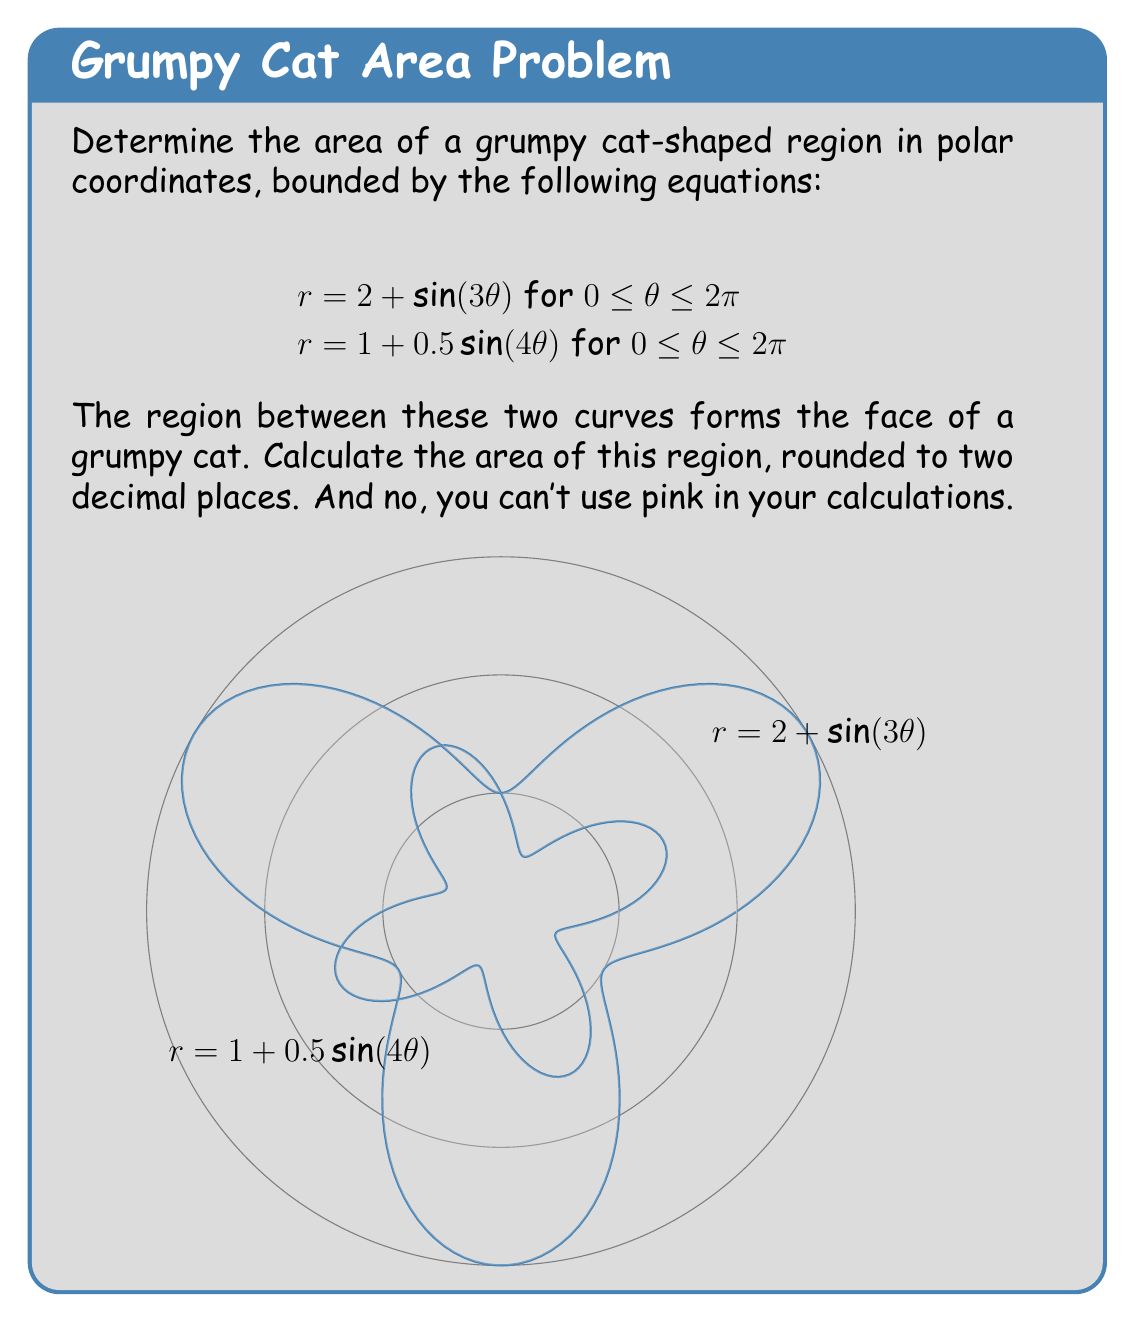Provide a solution to this math problem. To find the area of the region between two polar curves, we use the formula:

$$A = \frac{1}{2} \int_a^b [r_1(\theta)^2 - r_2(\theta)^2] d\theta$$

Where $r_1(\theta)$ is the outer curve and $r_2(\theta)$ is the inner curve.

In this case:
$r_1(\theta) = 2 + \sin(3\theta)$
$r_2(\theta) = 1 + 0.5\sin(4\theta)$
$a = 0$ and $b = 2\pi$

Let's substitute these into the formula:

$$A = \frac{1}{2} \int_0^{2\pi} [(2 + \sin(3\theta))^2 - (1 + 0.5\sin(4\theta))^2] d\theta$$

Expanding the squares:

$$A = \frac{1}{2} \int_0^{2\pi} [4 + 4\sin(3\theta) + \sin^2(3\theta) - 1 - \sin(4\theta) - 0.25\sin^2(4\theta)] d\theta$$

Simplifying:

$$A = \frac{1}{2} \int_0^{2\pi} [3 + 4\sin(3\theta) + \sin^2(3\theta) - \sin(4\theta) - 0.25\sin^2(4\theta)] d\theta$$

Now, we need to integrate each term:

1. $\int_0^{2\pi} 3 d\theta = 3\theta |_0^{2\pi} = 6\pi$

2. $\int_0^{2\pi} 4\sin(3\theta) d\theta = -\frac{4}{3}\cos(3\theta) |_0^{2\pi} = 0$

3. $\int_0^{2\pi} \sin^2(3\theta) d\theta = \int_0^{2\pi} \frac{1 - \cos(6\theta)}{2} d\theta = \frac{\theta}{2} - \frac{\sin(6\theta)}{12} |_0^{2\pi} = \pi$

4. $\int_0^{2\pi} -\sin(4\theta) d\theta = \frac{1}{4}\cos(4\theta) |_0^{2\pi} = 0$

5. $\int_0^{2\pi} -0.25\sin^2(4\theta) d\theta = -0.25 \int_0^{2\pi} \frac{1 - \cos(8\theta)}{2} d\theta = -\frac{\theta}{8} + \frac{\sin(8\theta)}{64} |_0^{2\pi} = -\frac{\pi}{4}$

Adding all these terms and multiplying by $\frac{1}{2}$:

$$A = \frac{1}{2}(6\pi + 0 + \pi + 0 - \frac{\pi}{4}) = \frac{27\pi}{8} \approx 10.60$$
Answer: The area of the grumpy cat-shaped region is approximately 10.60 square units. 